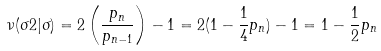Convert formula to latex. <formula><loc_0><loc_0><loc_500><loc_500>\nu ( \sigma 2 | \sigma ) = 2 \left ( \frac { p _ { n } } { p _ { n - 1 } } \right ) - 1 = 2 ( 1 - \frac { 1 } { 4 } p _ { n } ) - 1 = 1 - \frac { 1 } { 2 } p _ { n }</formula> 